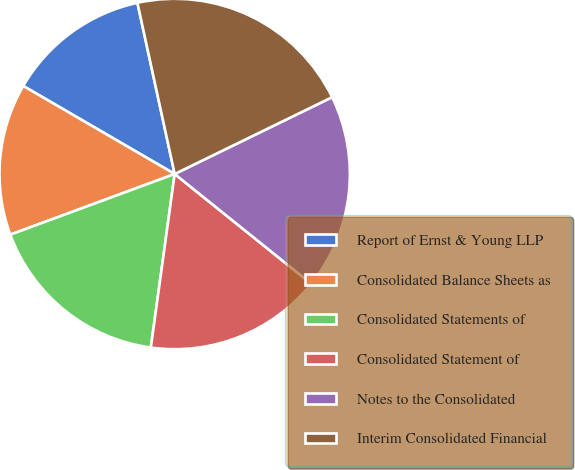Convert chart to OTSL. <chart><loc_0><loc_0><loc_500><loc_500><pie_chart><fcel>Report of Ernst & Young LLP<fcel>Consolidated Balance Sheets as<fcel>Consolidated Statements of<fcel>Consolidated Statement of<fcel>Notes to the Consolidated<fcel>Interim Consolidated Financial<nl><fcel>13.21%<fcel>14.01%<fcel>17.2%<fcel>16.4%<fcel>18.0%<fcel>21.19%<nl></chart> 